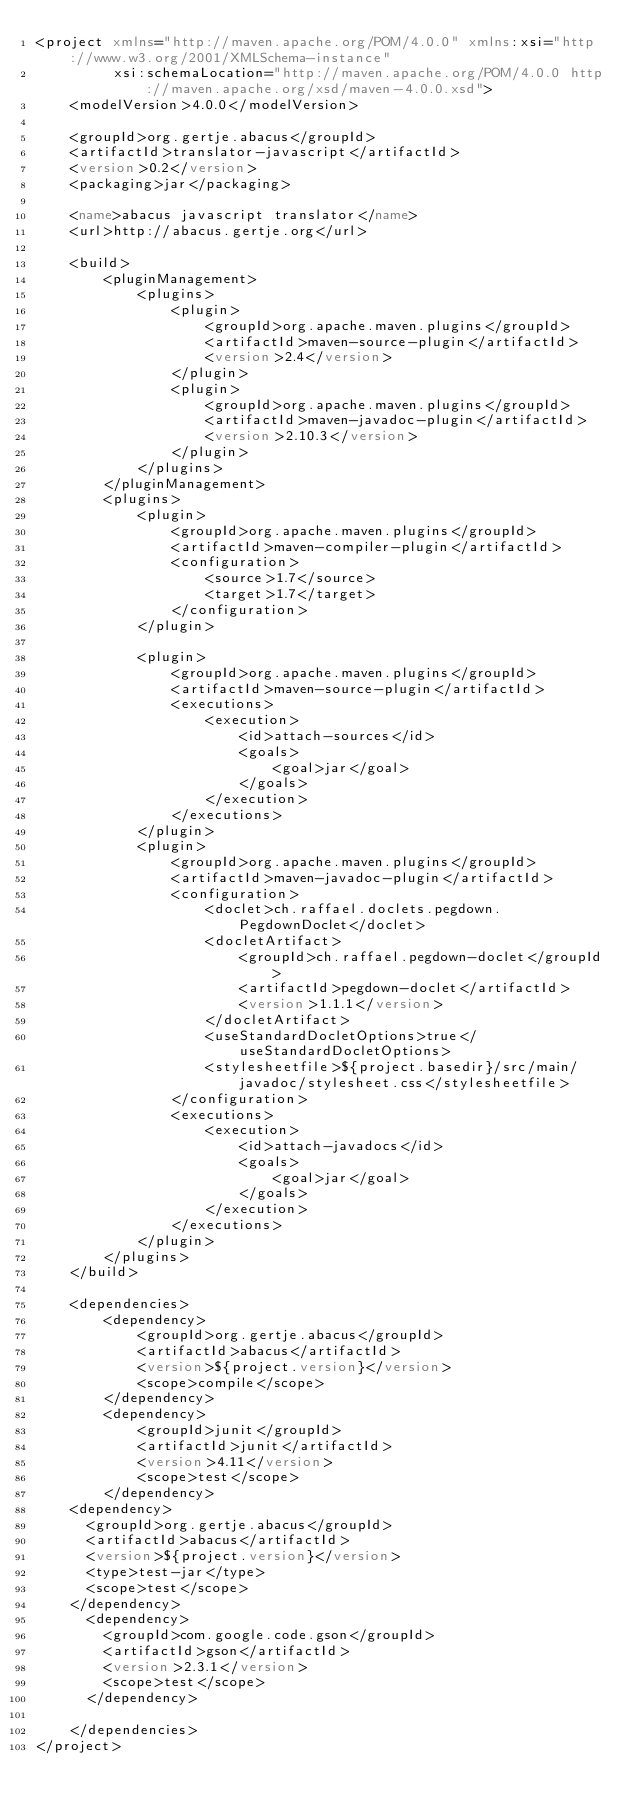Convert code to text. <code><loc_0><loc_0><loc_500><loc_500><_XML_><project xmlns="http://maven.apache.org/POM/4.0.0" xmlns:xsi="http://www.w3.org/2001/XMLSchema-instance"
         xsi:schemaLocation="http://maven.apache.org/POM/4.0.0 http://maven.apache.org/xsd/maven-4.0.0.xsd">
    <modelVersion>4.0.0</modelVersion>

    <groupId>org.gertje.abacus</groupId>
    <artifactId>translator-javascript</artifactId>
    <version>0.2</version>
    <packaging>jar</packaging>

    <name>abacus javascript translator</name>
    <url>http://abacus.gertje.org</url>

    <build>
        <pluginManagement>
            <plugins>
                <plugin>
                    <groupId>org.apache.maven.plugins</groupId>
                    <artifactId>maven-source-plugin</artifactId>
                    <version>2.4</version>
                </plugin>
                <plugin>
                    <groupId>org.apache.maven.plugins</groupId>
                    <artifactId>maven-javadoc-plugin</artifactId>
                    <version>2.10.3</version>
                </plugin>
            </plugins>
        </pluginManagement>
        <plugins>
            <plugin>
                <groupId>org.apache.maven.plugins</groupId>
                <artifactId>maven-compiler-plugin</artifactId>
                <configuration>
                    <source>1.7</source>
                    <target>1.7</target>
                </configuration>
            </plugin>

            <plugin>
                <groupId>org.apache.maven.plugins</groupId>
                <artifactId>maven-source-plugin</artifactId>
                <executions>
                    <execution>
                        <id>attach-sources</id>
                        <goals>
                            <goal>jar</goal>
                        </goals>
                    </execution>
                </executions>
            </plugin>
            <plugin>
                <groupId>org.apache.maven.plugins</groupId>
                <artifactId>maven-javadoc-plugin</artifactId>
                <configuration>
                    <doclet>ch.raffael.doclets.pegdown.PegdownDoclet</doclet>
                    <docletArtifact>
                        <groupId>ch.raffael.pegdown-doclet</groupId>
                        <artifactId>pegdown-doclet</artifactId>
                        <version>1.1.1</version>
                    </docletArtifact>
                    <useStandardDocletOptions>true</useStandardDocletOptions>
                    <stylesheetfile>${project.basedir}/src/main/javadoc/stylesheet.css</stylesheetfile>
                </configuration>
                <executions>
                    <execution>
                        <id>attach-javadocs</id>
                        <goals>
                            <goal>jar</goal>
                        </goals>
                    </execution>
                </executions>
            </plugin>
        </plugins>
    </build>

    <dependencies>
        <dependency>
            <groupId>org.gertje.abacus</groupId>
            <artifactId>abacus</artifactId>
            <version>${project.version}</version>
            <scope>compile</scope>
        </dependency>
        <dependency>
            <groupId>junit</groupId>
            <artifactId>junit</artifactId>
            <version>4.11</version>
            <scope>test</scope>
        </dependency>
		<dependency>
			<groupId>org.gertje.abacus</groupId>
			<artifactId>abacus</artifactId>
			<version>${project.version}</version>
			<type>test-jar</type>
			<scope>test</scope>
		</dependency>
	    <dependency>
		    <groupId>com.google.code.gson</groupId>
		    <artifactId>gson</artifactId>
		    <version>2.3.1</version>
		    <scope>test</scope>
	    </dependency>

    </dependencies>
</project></code> 